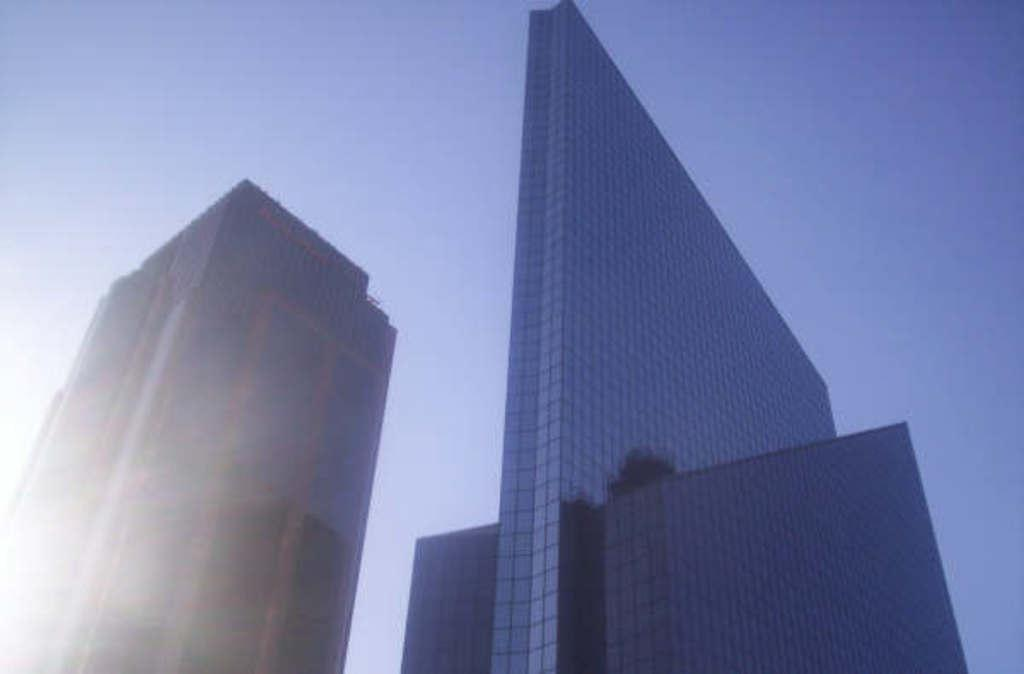What type of buildings can be seen in the image? There are skyscrapers in the image. Can you describe the height of the buildings? The skyscrapers are tall buildings, which is why they are called skyscrapers. What might be the purpose of these buildings? The skyscrapers could be used for offices, residences, or other commercial purposes. Are there any ghosts visible in the image? There are no ghosts present in the image; it features skyscrapers. Is there a stream running through the image? There is no stream visible in the image; it only shows skyscrapers. 